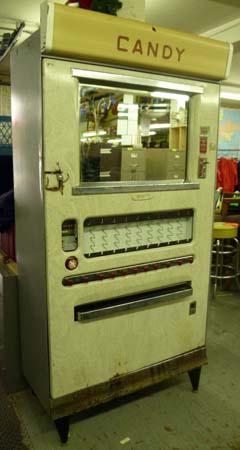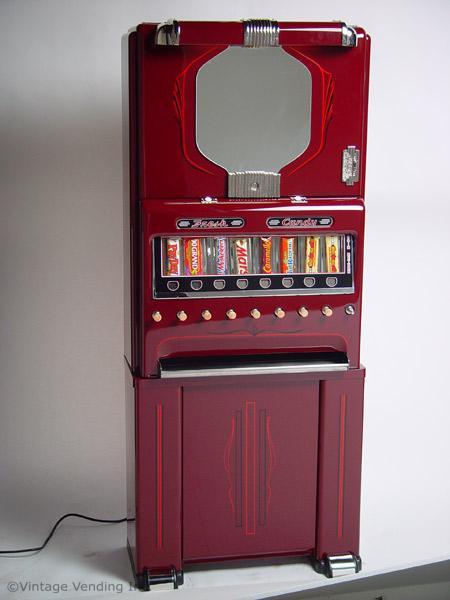The first image is the image on the left, the second image is the image on the right. Examine the images to the left and right. Is the description "Knobs can be seen beneath a single row of candies on the vending machine in one of the images." accurate? Answer yes or no. Yes. 